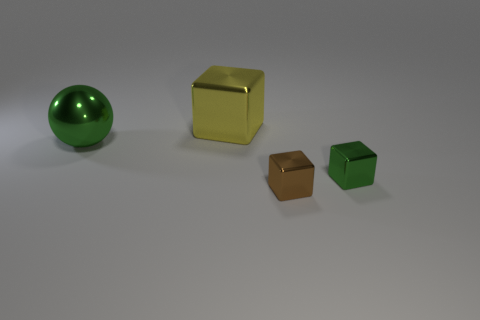What number of other objects are there of the same material as the yellow cube?
Provide a short and direct response. 3. Is the sphere made of the same material as the tiny brown cube?
Offer a very short reply. Yes. How many other things are there of the same size as the green sphere?
Provide a short and direct response. 1. What is the size of the yellow object behind the block that is in front of the green metallic block?
Give a very brief answer. Large. There is a block left of the tiny cube that is left of the green metallic thing to the right of the large ball; what color is it?
Your answer should be very brief. Yellow. There is a block that is behind the small brown metallic cube and in front of the large yellow metal block; what is its size?
Provide a succinct answer. Small. How many other things are there of the same shape as the big yellow object?
Offer a very short reply. 2. What number of cubes are either brown metal objects or big yellow shiny objects?
Ensure brevity in your answer.  2. Are there any tiny green metallic blocks that are on the right side of the large metallic thing that is on the right side of the big metallic thing in front of the yellow metal object?
Provide a succinct answer. Yes. What color is the big shiny thing that is the same shape as the tiny green shiny object?
Offer a very short reply. Yellow. 